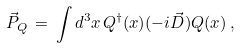<formula> <loc_0><loc_0><loc_500><loc_500>\vec { P } _ { Q } \, = \, \int d ^ { 3 } x \, Q ^ { \dagger } ( x ) ( - i \vec { D } ) Q ( x ) \, ,</formula> 